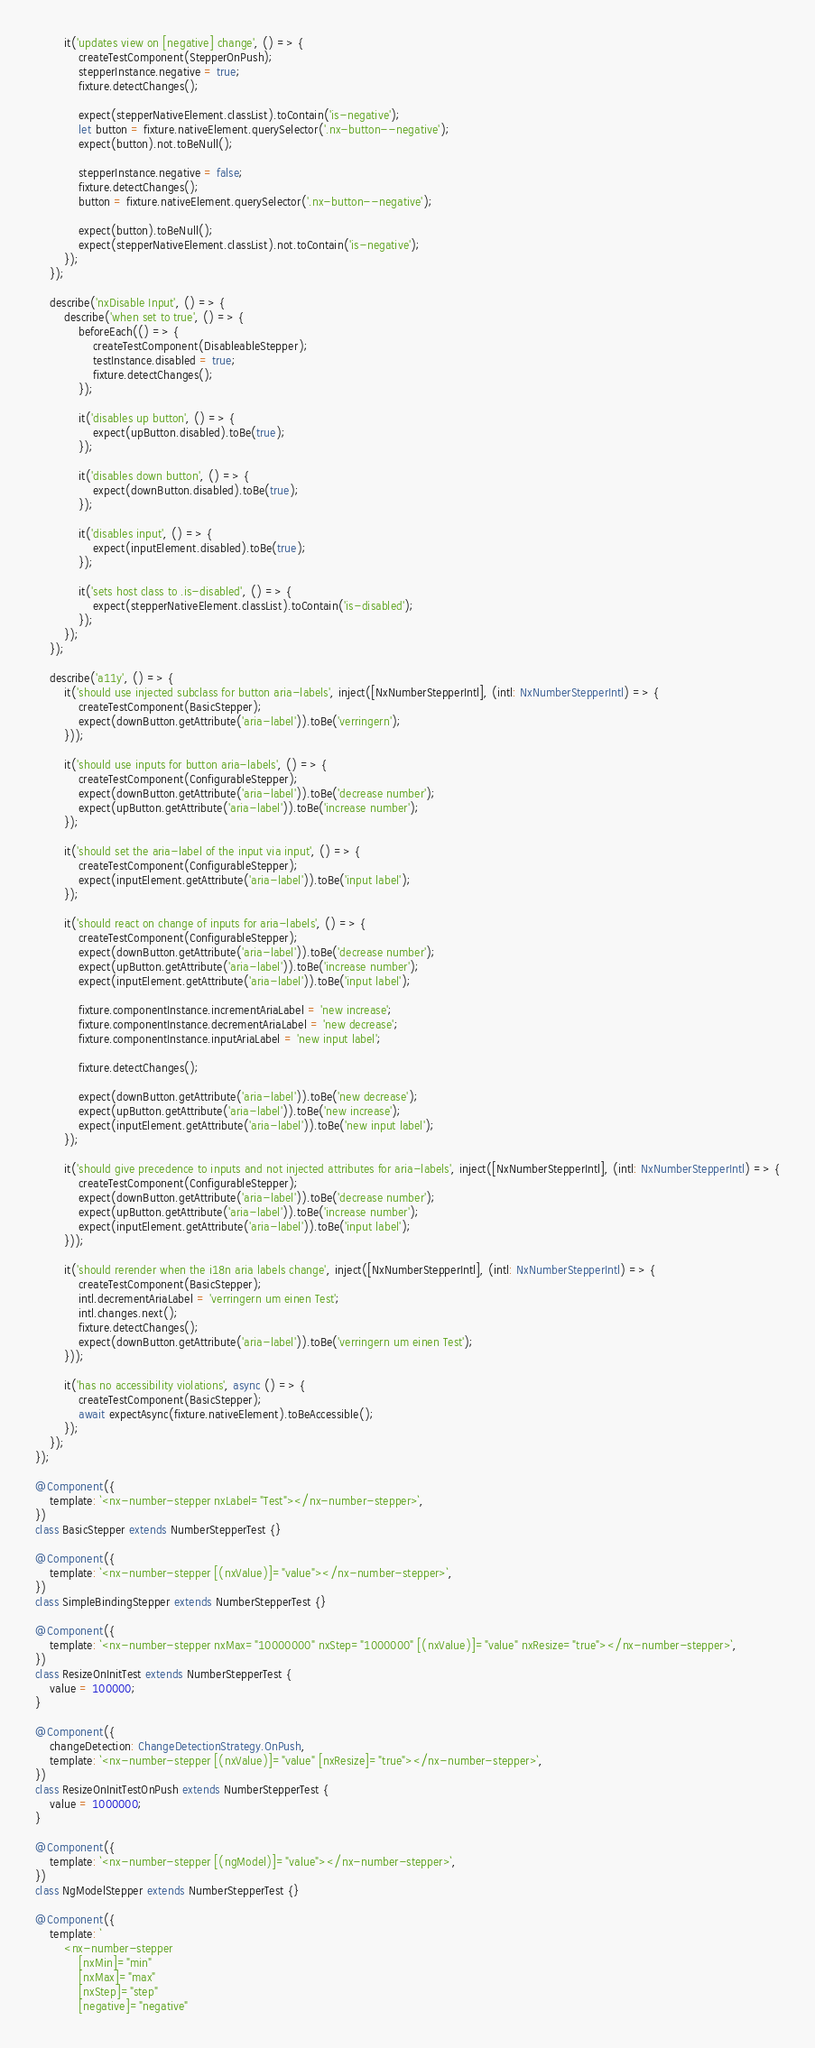Convert code to text. <code><loc_0><loc_0><loc_500><loc_500><_TypeScript_>        it('updates view on [negative] change', () => {
            createTestComponent(StepperOnPush);
            stepperInstance.negative = true;
            fixture.detectChanges();

            expect(stepperNativeElement.classList).toContain('is-negative');
            let button = fixture.nativeElement.querySelector('.nx-button--negative');
            expect(button).not.toBeNull();

            stepperInstance.negative = false;
            fixture.detectChanges();
            button = fixture.nativeElement.querySelector('.nx-button--negative');

            expect(button).toBeNull();
            expect(stepperNativeElement.classList).not.toContain('is-negative');
        });
    });

    describe('nxDisable Input', () => {
        describe('when set to true', () => {
            beforeEach(() => {
                createTestComponent(DisableableStepper);
                testInstance.disabled = true;
                fixture.detectChanges();
            });

            it('disables up button', () => {
                expect(upButton.disabled).toBe(true);
            });

            it('disables down button', () => {
                expect(downButton.disabled).toBe(true);
            });

            it('disables input', () => {
                expect(inputElement.disabled).toBe(true);
            });

            it('sets host class to .is-disabled', () => {
                expect(stepperNativeElement.classList).toContain('is-disabled');
            });
        });
    });

    describe('a11y', () => {
        it('should use injected subclass for button aria-labels', inject([NxNumberStepperIntl], (intl: NxNumberStepperIntl) => {
            createTestComponent(BasicStepper);
            expect(downButton.getAttribute('aria-label')).toBe('verringern');
        }));

        it('should use inputs for button aria-labels', () => {
            createTestComponent(ConfigurableStepper);
            expect(downButton.getAttribute('aria-label')).toBe('decrease number');
            expect(upButton.getAttribute('aria-label')).toBe('increase number');
        });

        it('should set the aria-label of the input via input', () => {
            createTestComponent(ConfigurableStepper);
            expect(inputElement.getAttribute('aria-label')).toBe('input label');
        });

        it('should react on change of inputs for aria-labels', () => {
            createTestComponent(ConfigurableStepper);
            expect(downButton.getAttribute('aria-label')).toBe('decrease number');
            expect(upButton.getAttribute('aria-label')).toBe('increase number');
            expect(inputElement.getAttribute('aria-label')).toBe('input label');

            fixture.componentInstance.incrementAriaLabel = 'new increase';
            fixture.componentInstance.decrementAriaLabel = 'new decrease';
            fixture.componentInstance.inputAriaLabel = 'new input label';

            fixture.detectChanges();

            expect(downButton.getAttribute('aria-label')).toBe('new decrease');
            expect(upButton.getAttribute('aria-label')).toBe('new increase');
            expect(inputElement.getAttribute('aria-label')).toBe('new input label');
        });

        it('should give precedence to inputs and not injected attributes for aria-labels', inject([NxNumberStepperIntl], (intl: NxNumberStepperIntl) => {
            createTestComponent(ConfigurableStepper);
            expect(downButton.getAttribute('aria-label')).toBe('decrease number');
            expect(upButton.getAttribute('aria-label')).toBe('increase number');
            expect(inputElement.getAttribute('aria-label')).toBe('input label');
        }));

        it('should rerender when the i18n aria labels change', inject([NxNumberStepperIntl], (intl: NxNumberStepperIntl) => {
            createTestComponent(BasicStepper);
            intl.decrementAriaLabel = 'verringern um einen Test';
            intl.changes.next();
            fixture.detectChanges();
            expect(downButton.getAttribute('aria-label')).toBe('verringern um einen Test');
        }));

        it('has no accessibility violations', async () => {
            createTestComponent(BasicStepper);
            await expectAsync(fixture.nativeElement).toBeAccessible();
        });
    });
});

@Component({
    template: `<nx-number-stepper nxLabel="Test"></nx-number-stepper>`,
})
class BasicStepper extends NumberStepperTest {}

@Component({
    template: `<nx-number-stepper [(nxValue)]="value"></nx-number-stepper>`,
})
class SimpleBindingStepper extends NumberStepperTest {}

@Component({
    template: `<nx-number-stepper nxMax="10000000" nxStep="1000000" [(nxValue)]="value" nxResize="true"></nx-number-stepper>`,
})
class ResizeOnInitTest extends NumberStepperTest {
    value = 100000;
}

@Component({
    changeDetection: ChangeDetectionStrategy.OnPush,
    template: `<nx-number-stepper [(nxValue)]="value" [nxResize]="true"></nx-number-stepper>`,
})
class ResizeOnInitTestOnPush extends NumberStepperTest {
    value = 1000000;
}

@Component({
    template: `<nx-number-stepper [(ngModel)]="value"></nx-number-stepper>`,
})
class NgModelStepper extends NumberStepperTest {}

@Component({
    template: `
        <nx-number-stepper
            [nxMin]="min"
            [nxMax]="max"
            [nxStep]="step"
            [negative]="negative"</code> 